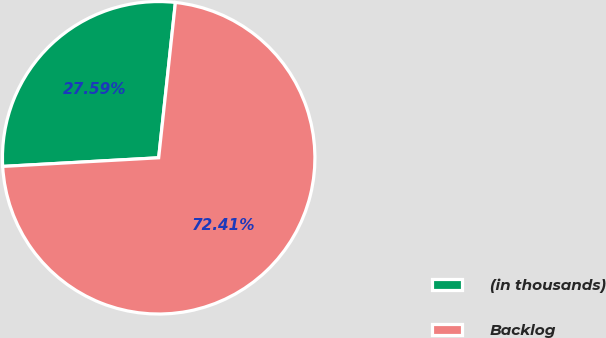<chart> <loc_0><loc_0><loc_500><loc_500><pie_chart><fcel>(in thousands)<fcel>Backlog<nl><fcel>27.59%<fcel>72.41%<nl></chart> 